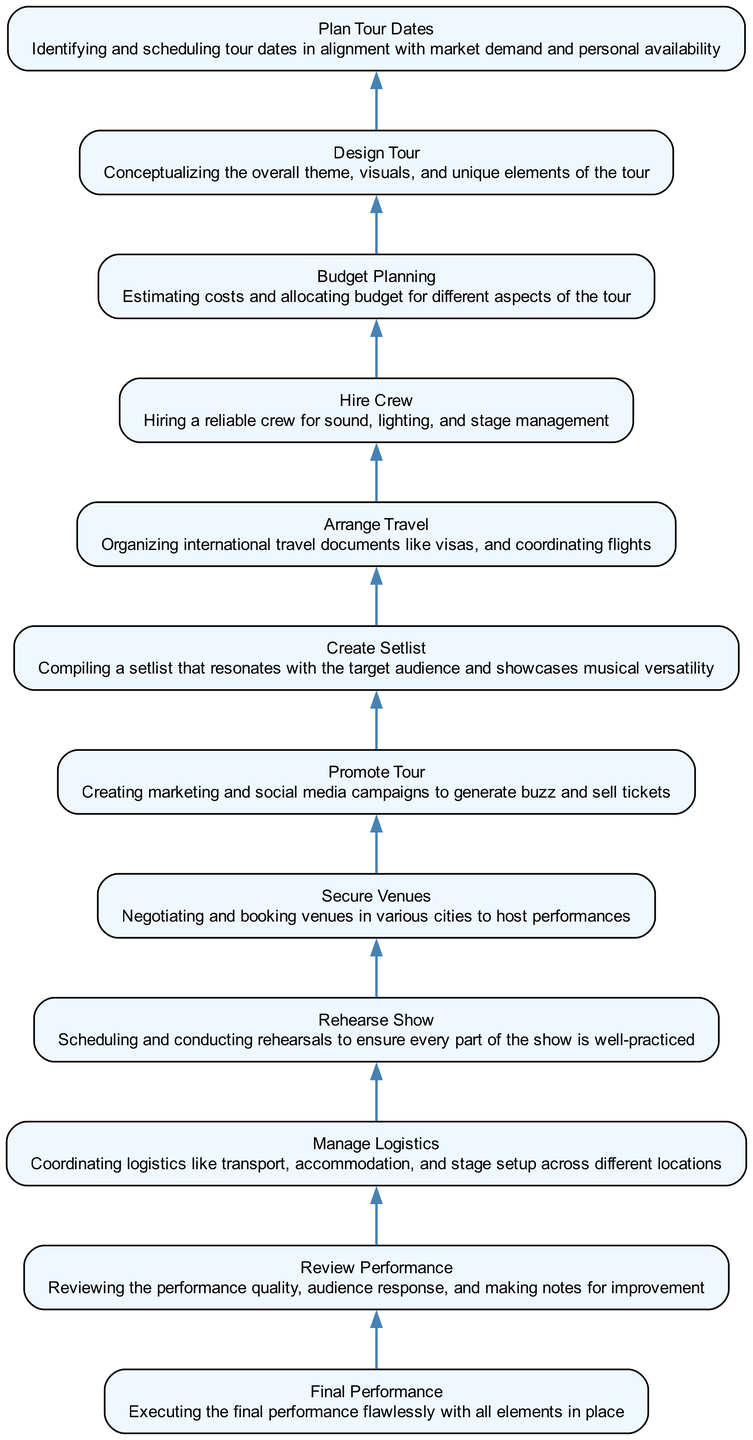What is the first step in organizing an international music tour? The diagram shows that the first step is to plan the tour dates. This is the bottom node and serves as the foundation for further steps.
Answer: Plan tour dates How many steps are involved in the journey of organizing the tour? By counting the nodes in the flowchart, there are a total of 12 steps listed from planning to the final performance.
Answer: 12 What is the second-to-last step before the final performance? The diagram indicates that the step immediately before the final performance is reviewing the performance. This node is directly linked to the final performance node.
Answer: Review performance Which step involves creating marketing campaigns? The node promoting the tour refers specifically to creating marketing and social media campaigns. It indicates the efforts taken to generate buzz and sell tickets.
Answer: Promote tour Which two steps need to be completed before managing logistics? The steps that come before managing logistics in the flowchart are hiring a crew and arranging travel. Both these nodes must be addressed prior to coordinating logistics.
Answer: Hire crew, arrange travel What is required before securing the venues? The node for budget planning must be completed first. To negotiate and book venues, one must have a clear understanding of the budget allocated for the tour.
Answer: Budget planning What is a consequence of not creating a setlist? The diagram suggests that if a setlist is not created, it can negatively impact the rehearsals, as a well-defined setlist is essential for a successful show preparation.
Answer: Impacts rehearsals What is the main objective of arranging travel? The objective expressed in the node for arranging travel is to organize international travel documents like visas and coordinating flights to ensure smooth transitions for the tour.
Answer: Organizing international travel documents Which step involves a coordination of various cities? The process of securing venues involves negotiating and booking sites in different cities where performances will take place. This indicates the geographical aspect of the touring process.
Answer: Securing venues 